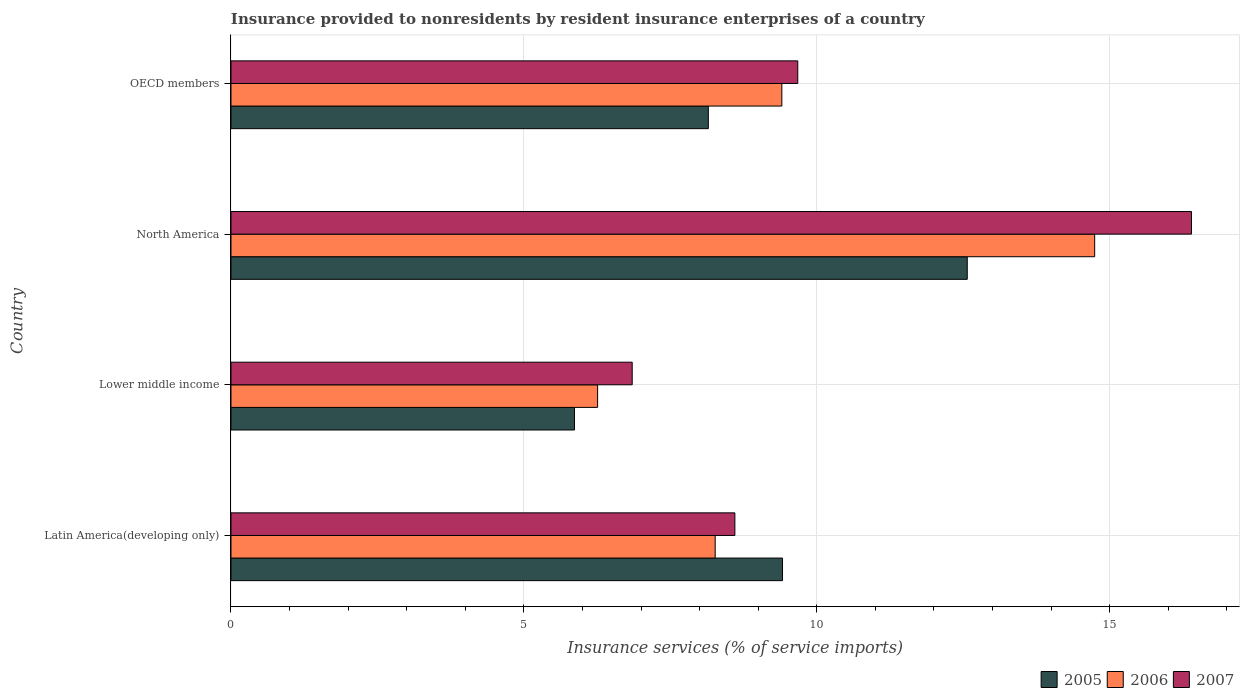How many different coloured bars are there?
Your answer should be very brief. 3. Are the number of bars per tick equal to the number of legend labels?
Give a very brief answer. Yes. What is the label of the 4th group of bars from the top?
Provide a succinct answer. Latin America(developing only). What is the insurance provided to nonresidents in 2005 in Latin America(developing only)?
Offer a very short reply. 9.41. Across all countries, what is the maximum insurance provided to nonresidents in 2006?
Your response must be concise. 14.74. Across all countries, what is the minimum insurance provided to nonresidents in 2006?
Your answer should be very brief. 6.26. In which country was the insurance provided to nonresidents in 2006 minimum?
Provide a short and direct response. Lower middle income. What is the total insurance provided to nonresidents in 2005 in the graph?
Make the answer very short. 36. What is the difference between the insurance provided to nonresidents in 2007 in North America and that in OECD members?
Your response must be concise. 6.72. What is the difference between the insurance provided to nonresidents in 2007 in Lower middle income and the insurance provided to nonresidents in 2006 in Latin America(developing only)?
Offer a very short reply. -1.42. What is the average insurance provided to nonresidents in 2006 per country?
Provide a short and direct response. 9.67. What is the difference between the insurance provided to nonresidents in 2007 and insurance provided to nonresidents in 2005 in Lower middle income?
Provide a succinct answer. 0.99. In how many countries, is the insurance provided to nonresidents in 2007 greater than 3 %?
Provide a short and direct response. 4. What is the ratio of the insurance provided to nonresidents in 2007 in North America to that in OECD members?
Offer a terse response. 1.69. Is the difference between the insurance provided to nonresidents in 2007 in North America and OECD members greater than the difference between the insurance provided to nonresidents in 2005 in North America and OECD members?
Ensure brevity in your answer.  Yes. What is the difference between the highest and the second highest insurance provided to nonresidents in 2007?
Offer a very short reply. 6.72. What is the difference between the highest and the lowest insurance provided to nonresidents in 2006?
Provide a short and direct response. 8.48. Is the sum of the insurance provided to nonresidents in 2006 in Lower middle income and OECD members greater than the maximum insurance provided to nonresidents in 2007 across all countries?
Provide a succinct answer. No. What does the 3rd bar from the top in Lower middle income represents?
Offer a terse response. 2005. How many bars are there?
Make the answer very short. 12. Are the values on the major ticks of X-axis written in scientific E-notation?
Your answer should be very brief. No. Where does the legend appear in the graph?
Provide a short and direct response. Bottom right. How are the legend labels stacked?
Your response must be concise. Horizontal. What is the title of the graph?
Provide a short and direct response. Insurance provided to nonresidents by resident insurance enterprises of a country. What is the label or title of the X-axis?
Provide a succinct answer. Insurance services (% of service imports). What is the label or title of the Y-axis?
Your answer should be compact. Country. What is the Insurance services (% of service imports) of 2005 in Latin America(developing only)?
Make the answer very short. 9.41. What is the Insurance services (% of service imports) of 2006 in Latin America(developing only)?
Offer a very short reply. 8.27. What is the Insurance services (% of service imports) of 2007 in Latin America(developing only)?
Provide a succinct answer. 8.6. What is the Insurance services (% of service imports) of 2005 in Lower middle income?
Your answer should be compact. 5.86. What is the Insurance services (% of service imports) of 2006 in Lower middle income?
Offer a terse response. 6.26. What is the Insurance services (% of service imports) in 2007 in Lower middle income?
Provide a short and direct response. 6.85. What is the Insurance services (% of service imports) of 2005 in North America?
Your answer should be compact. 12.57. What is the Insurance services (% of service imports) in 2006 in North America?
Your answer should be compact. 14.74. What is the Insurance services (% of service imports) of 2007 in North America?
Ensure brevity in your answer.  16.4. What is the Insurance services (% of service imports) of 2005 in OECD members?
Your response must be concise. 8.15. What is the Insurance services (% of service imports) of 2006 in OECD members?
Provide a succinct answer. 9.4. What is the Insurance services (% of service imports) in 2007 in OECD members?
Make the answer very short. 9.68. Across all countries, what is the maximum Insurance services (% of service imports) in 2005?
Ensure brevity in your answer.  12.57. Across all countries, what is the maximum Insurance services (% of service imports) in 2006?
Make the answer very short. 14.74. Across all countries, what is the maximum Insurance services (% of service imports) of 2007?
Your response must be concise. 16.4. Across all countries, what is the minimum Insurance services (% of service imports) of 2005?
Offer a very short reply. 5.86. Across all countries, what is the minimum Insurance services (% of service imports) of 2006?
Keep it short and to the point. 6.26. Across all countries, what is the minimum Insurance services (% of service imports) of 2007?
Offer a very short reply. 6.85. What is the total Insurance services (% of service imports) in 2005 in the graph?
Your answer should be compact. 36. What is the total Insurance services (% of service imports) of 2006 in the graph?
Provide a succinct answer. 38.67. What is the total Insurance services (% of service imports) of 2007 in the graph?
Offer a terse response. 41.52. What is the difference between the Insurance services (% of service imports) of 2005 in Latin America(developing only) and that in Lower middle income?
Give a very brief answer. 3.55. What is the difference between the Insurance services (% of service imports) of 2006 in Latin America(developing only) and that in Lower middle income?
Make the answer very short. 2.01. What is the difference between the Insurance services (% of service imports) of 2007 in Latin America(developing only) and that in Lower middle income?
Keep it short and to the point. 1.75. What is the difference between the Insurance services (% of service imports) of 2005 in Latin America(developing only) and that in North America?
Your answer should be compact. -3.15. What is the difference between the Insurance services (% of service imports) of 2006 in Latin America(developing only) and that in North America?
Provide a succinct answer. -6.48. What is the difference between the Insurance services (% of service imports) of 2007 in Latin America(developing only) and that in North America?
Ensure brevity in your answer.  -7.79. What is the difference between the Insurance services (% of service imports) of 2005 in Latin America(developing only) and that in OECD members?
Your answer should be compact. 1.27. What is the difference between the Insurance services (% of service imports) in 2006 in Latin America(developing only) and that in OECD members?
Offer a terse response. -1.14. What is the difference between the Insurance services (% of service imports) in 2007 in Latin America(developing only) and that in OECD members?
Offer a very short reply. -1.07. What is the difference between the Insurance services (% of service imports) in 2005 in Lower middle income and that in North America?
Make the answer very short. -6.71. What is the difference between the Insurance services (% of service imports) of 2006 in Lower middle income and that in North America?
Your response must be concise. -8.48. What is the difference between the Insurance services (% of service imports) in 2007 in Lower middle income and that in North America?
Make the answer very short. -9.55. What is the difference between the Insurance services (% of service imports) of 2005 in Lower middle income and that in OECD members?
Provide a succinct answer. -2.29. What is the difference between the Insurance services (% of service imports) in 2006 in Lower middle income and that in OECD members?
Your answer should be compact. -3.14. What is the difference between the Insurance services (% of service imports) in 2007 in Lower middle income and that in OECD members?
Keep it short and to the point. -2.83. What is the difference between the Insurance services (% of service imports) of 2005 in North America and that in OECD members?
Provide a short and direct response. 4.42. What is the difference between the Insurance services (% of service imports) in 2006 in North America and that in OECD members?
Ensure brevity in your answer.  5.34. What is the difference between the Insurance services (% of service imports) in 2007 in North America and that in OECD members?
Provide a succinct answer. 6.72. What is the difference between the Insurance services (% of service imports) of 2005 in Latin America(developing only) and the Insurance services (% of service imports) of 2006 in Lower middle income?
Your answer should be compact. 3.16. What is the difference between the Insurance services (% of service imports) in 2005 in Latin America(developing only) and the Insurance services (% of service imports) in 2007 in Lower middle income?
Offer a terse response. 2.57. What is the difference between the Insurance services (% of service imports) of 2006 in Latin America(developing only) and the Insurance services (% of service imports) of 2007 in Lower middle income?
Offer a terse response. 1.42. What is the difference between the Insurance services (% of service imports) in 2005 in Latin America(developing only) and the Insurance services (% of service imports) in 2006 in North America?
Offer a very short reply. -5.33. What is the difference between the Insurance services (% of service imports) of 2005 in Latin America(developing only) and the Insurance services (% of service imports) of 2007 in North America?
Your answer should be compact. -6.98. What is the difference between the Insurance services (% of service imports) of 2006 in Latin America(developing only) and the Insurance services (% of service imports) of 2007 in North America?
Offer a very short reply. -8.13. What is the difference between the Insurance services (% of service imports) of 2005 in Latin America(developing only) and the Insurance services (% of service imports) of 2006 in OECD members?
Give a very brief answer. 0.01. What is the difference between the Insurance services (% of service imports) in 2005 in Latin America(developing only) and the Insurance services (% of service imports) in 2007 in OECD members?
Your answer should be compact. -0.26. What is the difference between the Insurance services (% of service imports) in 2006 in Latin America(developing only) and the Insurance services (% of service imports) in 2007 in OECD members?
Make the answer very short. -1.41. What is the difference between the Insurance services (% of service imports) in 2005 in Lower middle income and the Insurance services (% of service imports) in 2006 in North America?
Offer a very short reply. -8.88. What is the difference between the Insurance services (% of service imports) of 2005 in Lower middle income and the Insurance services (% of service imports) of 2007 in North America?
Ensure brevity in your answer.  -10.53. What is the difference between the Insurance services (% of service imports) in 2006 in Lower middle income and the Insurance services (% of service imports) in 2007 in North America?
Offer a terse response. -10.14. What is the difference between the Insurance services (% of service imports) in 2005 in Lower middle income and the Insurance services (% of service imports) in 2006 in OECD members?
Your answer should be very brief. -3.54. What is the difference between the Insurance services (% of service imports) in 2005 in Lower middle income and the Insurance services (% of service imports) in 2007 in OECD members?
Provide a succinct answer. -3.81. What is the difference between the Insurance services (% of service imports) of 2006 in Lower middle income and the Insurance services (% of service imports) of 2007 in OECD members?
Offer a terse response. -3.42. What is the difference between the Insurance services (% of service imports) of 2005 in North America and the Insurance services (% of service imports) of 2006 in OECD members?
Give a very brief answer. 3.17. What is the difference between the Insurance services (% of service imports) in 2005 in North America and the Insurance services (% of service imports) in 2007 in OECD members?
Offer a terse response. 2.89. What is the difference between the Insurance services (% of service imports) of 2006 in North America and the Insurance services (% of service imports) of 2007 in OECD members?
Offer a very short reply. 5.07. What is the average Insurance services (% of service imports) of 2005 per country?
Make the answer very short. 9. What is the average Insurance services (% of service imports) of 2006 per country?
Your answer should be very brief. 9.67. What is the average Insurance services (% of service imports) in 2007 per country?
Ensure brevity in your answer.  10.38. What is the difference between the Insurance services (% of service imports) in 2005 and Insurance services (% of service imports) in 2006 in Latin America(developing only)?
Your response must be concise. 1.15. What is the difference between the Insurance services (% of service imports) in 2005 and Insurance services (% of service imports) in 2007 in Latin America(developing only)?
Ensure brevity in your answer.  0.81. What is the difference between the Insurance services (% of service imports) in 2006 and Insurance services (% of service imports) in 2007 in Latin America(developing only)?
Ensure brevity in your answer.  -0.34. What is the difference between the Insurance services (% of service imports) of 2005 and Insurance services (% of service imports) of 2006 in Lower middle income?
Keep it short and to the point. -0.4. What is the difference between the Insurance services (% of service imports) in 2005 and Insurance services (% of service imports) in 2007 in Lower middle income?
Your response must be concise. -0.99. What is the difference between the Insurance services (% of service imports) of 2006 and Insurance services (% of service imports) of 2007 in Lower middle income?
Make the answer very short. -0.59. What is the difference between the Insurance services (% of service imports) of 2005 and Insurance services (% of service imports) of 2006 in North America?
Your answer should be very brief. -2.17. What is the difference between the Insurance services (% of service imports) of 2005 and Insurance services (% of service imports) of 2007 in North America?
Your answer should be compact. -3.83. What is the difference between the Insurance services (% of service imports) of 2006 and Insurance services (% of service imports) of 2007 in North America?
Your answer should be compact. -1.65. What is the difference between the Insurance services (% of service imports) of 2005 and Insurance services (% of service imports) of 2006 in OECD members?
Your response must be concise. -1.25. What is the difference between the Insurance services (% of service imports) in 2005 and Insurance services (% of service imports) in 2007 in OECD members?
Offer a very short reply. -1.53. What is the difference between the Insurance services (% of service imports) in 2006 and Insurance services (% of service imports) in 2007 in OECD members?
Offer a terse response. -0.27. What is the ratio of the Insurance services (% of service imports) in 2005 in Latin America(developing only) to that in Lower middle income?
Offer a very short reply. 1.61. What is the ratio of the Insurance services (% of service imports) of 2006 in Latin America(developing only) to that in Lower middle income?
Your response must be concise. 1.32. What is the ratio of the Insurance services (% of service imports) of 2007 in Latin America(developing only) to that in Lower middle income?
Ensure brevity in your answer.  1.26. What is the ratio of the Insurance services (% of service imports) of 2005 in Latin America(developing only) to that in North America?
Give a very brief answer. 0.75. What is the ratio of the Insurance services (% of service imports) of 2006 in Latin America(developing only) to that in North America?
Make the answer very short. 0.56. What is the ratio of the Insurance services (% of service imports) in 2007 in Latin America(developing only) to that in North America?
Keep it short and to the point. 0.52. What is the ratio of the Insurance services (% of service imports) of 2005 in Latin America(developing only) to that in OECD members?
Ensure brevity in your answer.  1.16. What is the ratio of the Insurance services (% of service imports) in 2006 in Latin America(developing only) to that in OECD members?
Provide a succinct answer. 0.88. What is the ratio of the Insurance services (% of service imports) in 2007 in Latin America(developing only) to that in OECD members?
Your response must be concise. 0.89. What is the ratio of the Insurance services (% of service imports) of 2005 in Lower middle income to that in North America?
Your answer should be compact. 0.47. What is the ratio of the Insurance services (% of service imports) in 2006 in Lower middle income to that in North America?
Your response must be concise. 0.42. What is the ratio of the Insurance services (% of service imports) in 2007 in Lower middle income to that in North America?
Your response must be concise. 0.42. What is the ratio of the Insurance services (% of service imports) of 2005 in Lower middle income to that in OECD members?
Your response must be concise. 0.72. What is the ratio of the Insurance services (% of service imports) of 2006 in Lower middle income to that in OECD members?
Give a very brief answer. 0.67. What is the ratio of the Insurance services (% of service imports) in 2007 in Lower middle income to that in OECD members?
Offer a very short reply. 0.71. What is the ratio of the Insurance services (% of service imports) of 2005 in North America to that in OECD members?
Your answer should be compact. 1.54. What is the ratio of the Insurance services (% of service imports) of 2006 in North America to that in OECD members?
Ensure brevity in your answer.  1.57. What is the ratio of the Insurance services (% of service imports) in 2007 in North America to that in OECD members?
Offer a very short reply. 1.69. What is the difference between the highest and the second highest Insurance services (% of service imports) in 2005?
Offer a terse response. 3.15. What is the difference between the highest and the second highest Insurance services (% of service imports) in 2006?
Your response must be concise. 5.34. What is the difference between the highest and the second highest Insurance services (% of service imports) of 2007?
Keep it short and to the point. 6.72. What is the difference between the highest and the lowest Insurance services (% of service imports) of 2005?
Offer a terse response. 6.71. What is the difference between the highest and the lowest Insurance services (% of service imports) in 2006?
Ensure brevity in your answer.  8.48. What is the difference between the highest and the lowest Insurance services (% of service imports) in 2007?
Your answer should be compact. 9.55. 